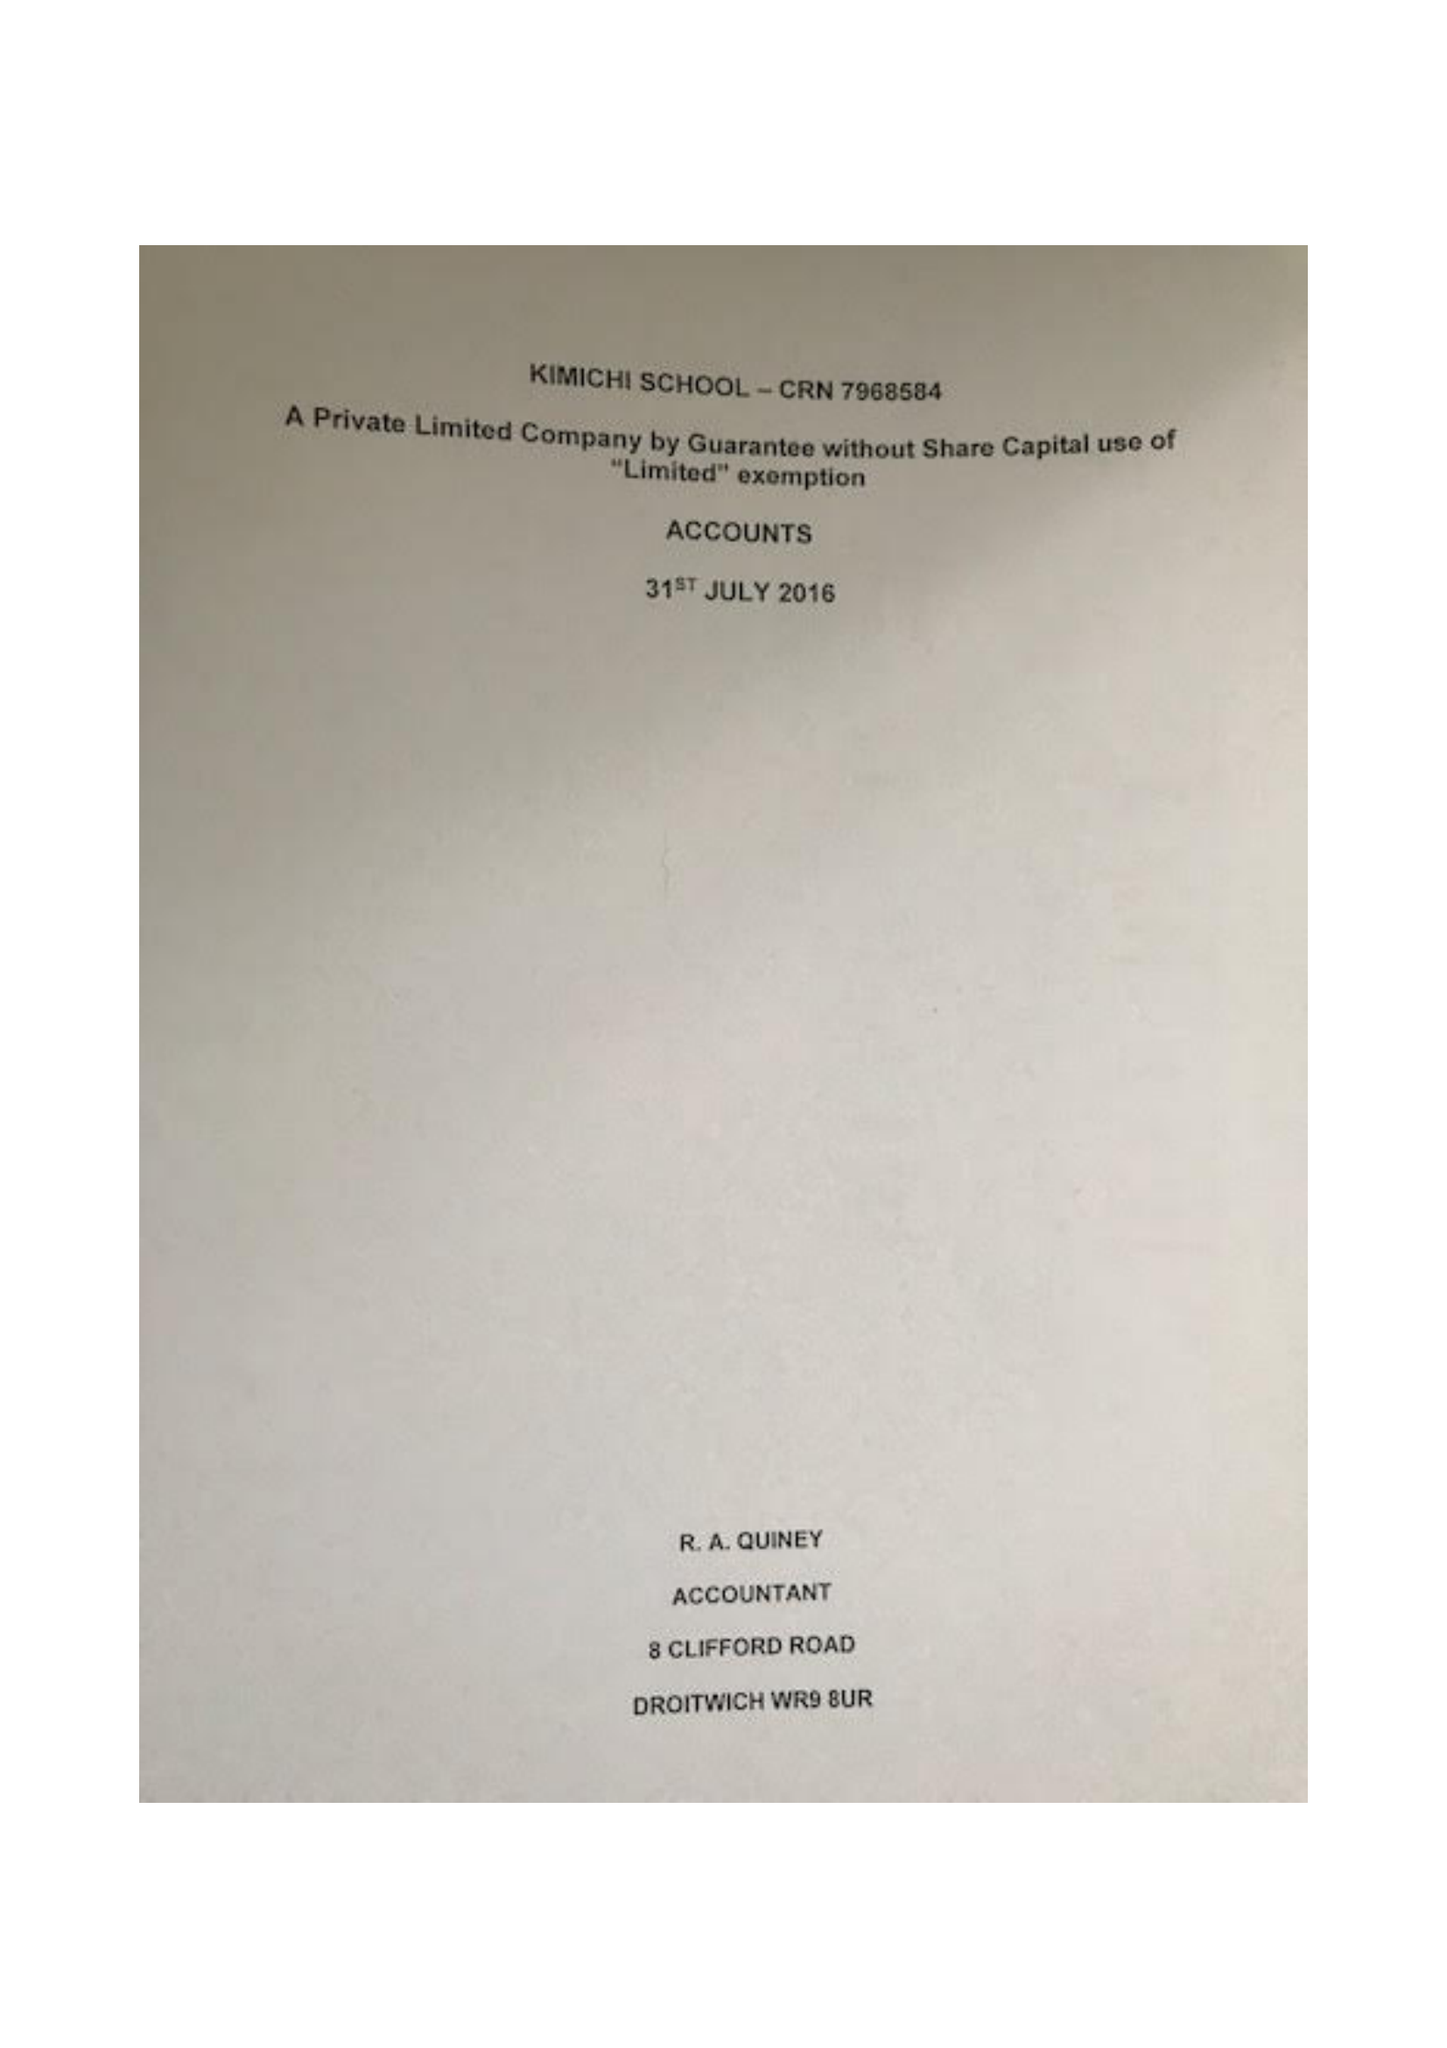What is the value for the spending_annually_in_british_pounds?
Answer the question using a single word or phrase. 46742.00 